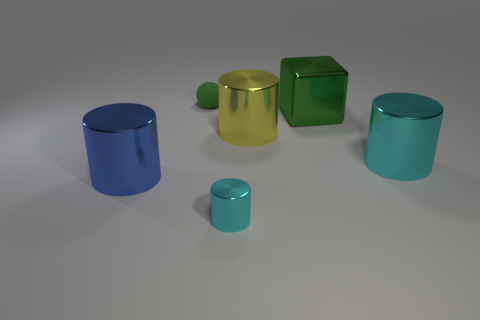Subtract all cyan balls. How many cyan cylinders are left? 2 Subtract all yellow shiny cylinders. How many cylinders are left? 3 Subtract all blue cylinders. How many cylinders are left? 3 Add 2 small red things. How many objects exist? 8 Subtract all blocks. How many objects are left? 5 Subtract all purple cylinders. Subtract all red blocks. How many cylinders are left? 4 Subtract all cyan metal cylinders. Subtract all small cyan objects. How many objects are left? 3 Add 4 large green metallic things. How many large green metallic things are left? 5 Add 5 big gray cylinders. How many big gray cylinders exist? 5 Subtract 0 cyan spheres. How many objects are left? 6 